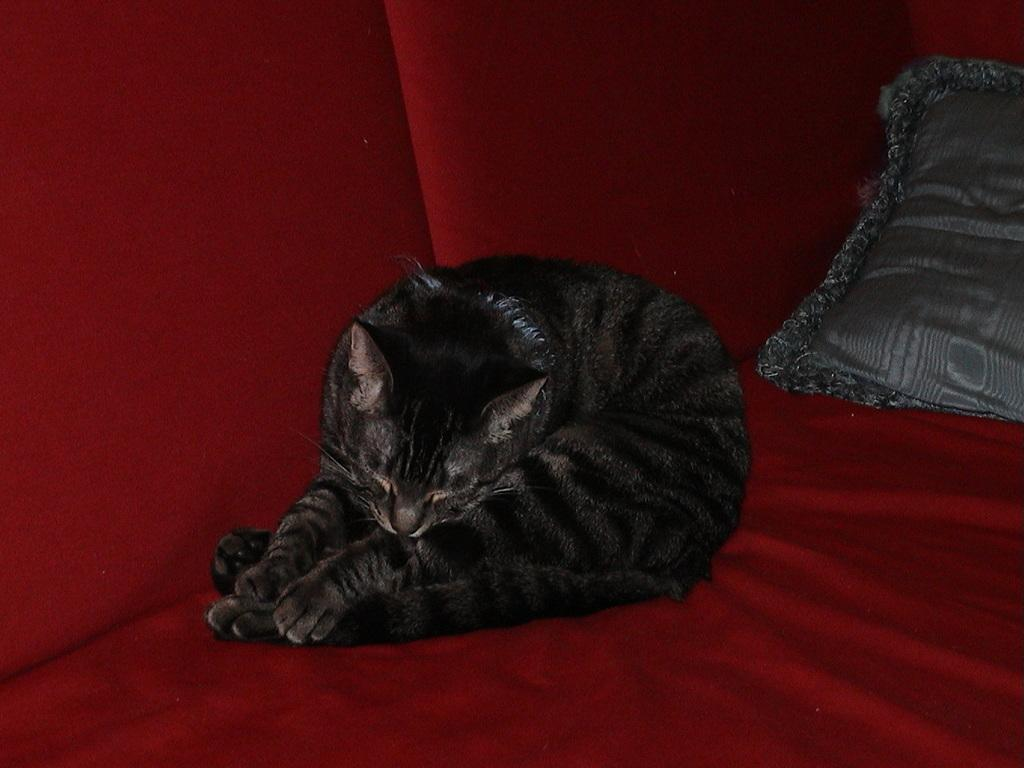What type of animal is in the image? There is a cat in the image. Where is the cat located? The cat is on a couch. What other object can be seen in the image? There is a pillow in the image. How many toes can be seen on the cat's paws in the image? The number of toes on the cat's paws cannot be determined from the image, as the cat's paws are not visible. 